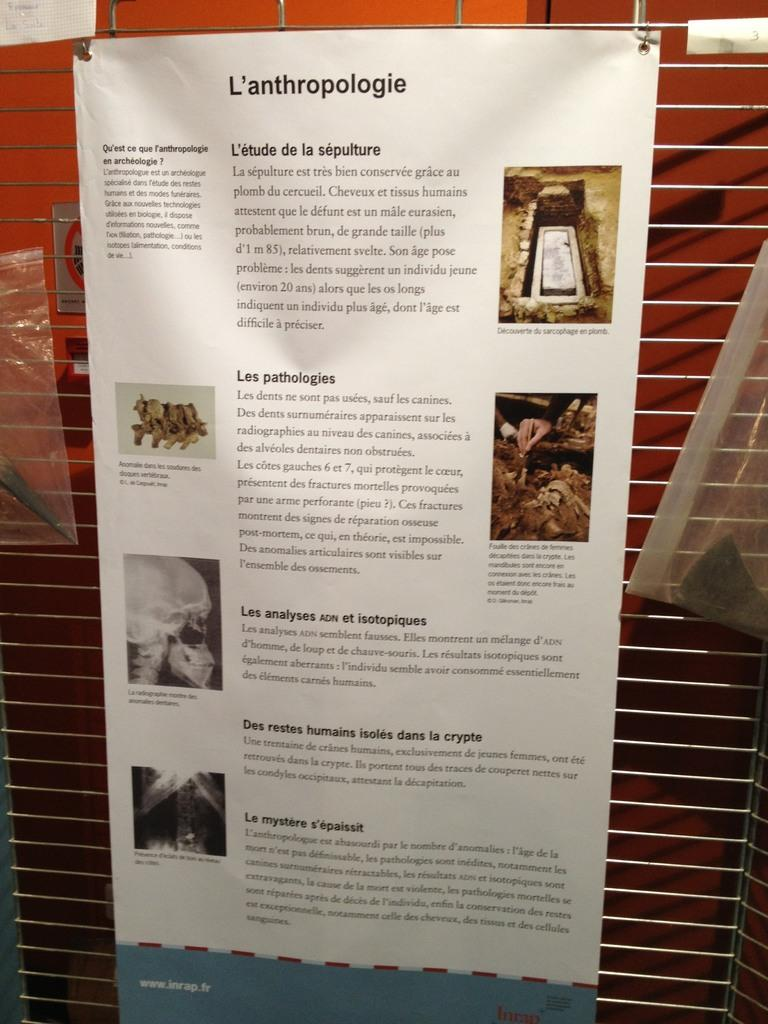Provide a one-sentence caption for the provided image. A paper hung on a wall that has "L'anthropologie" on the top. 